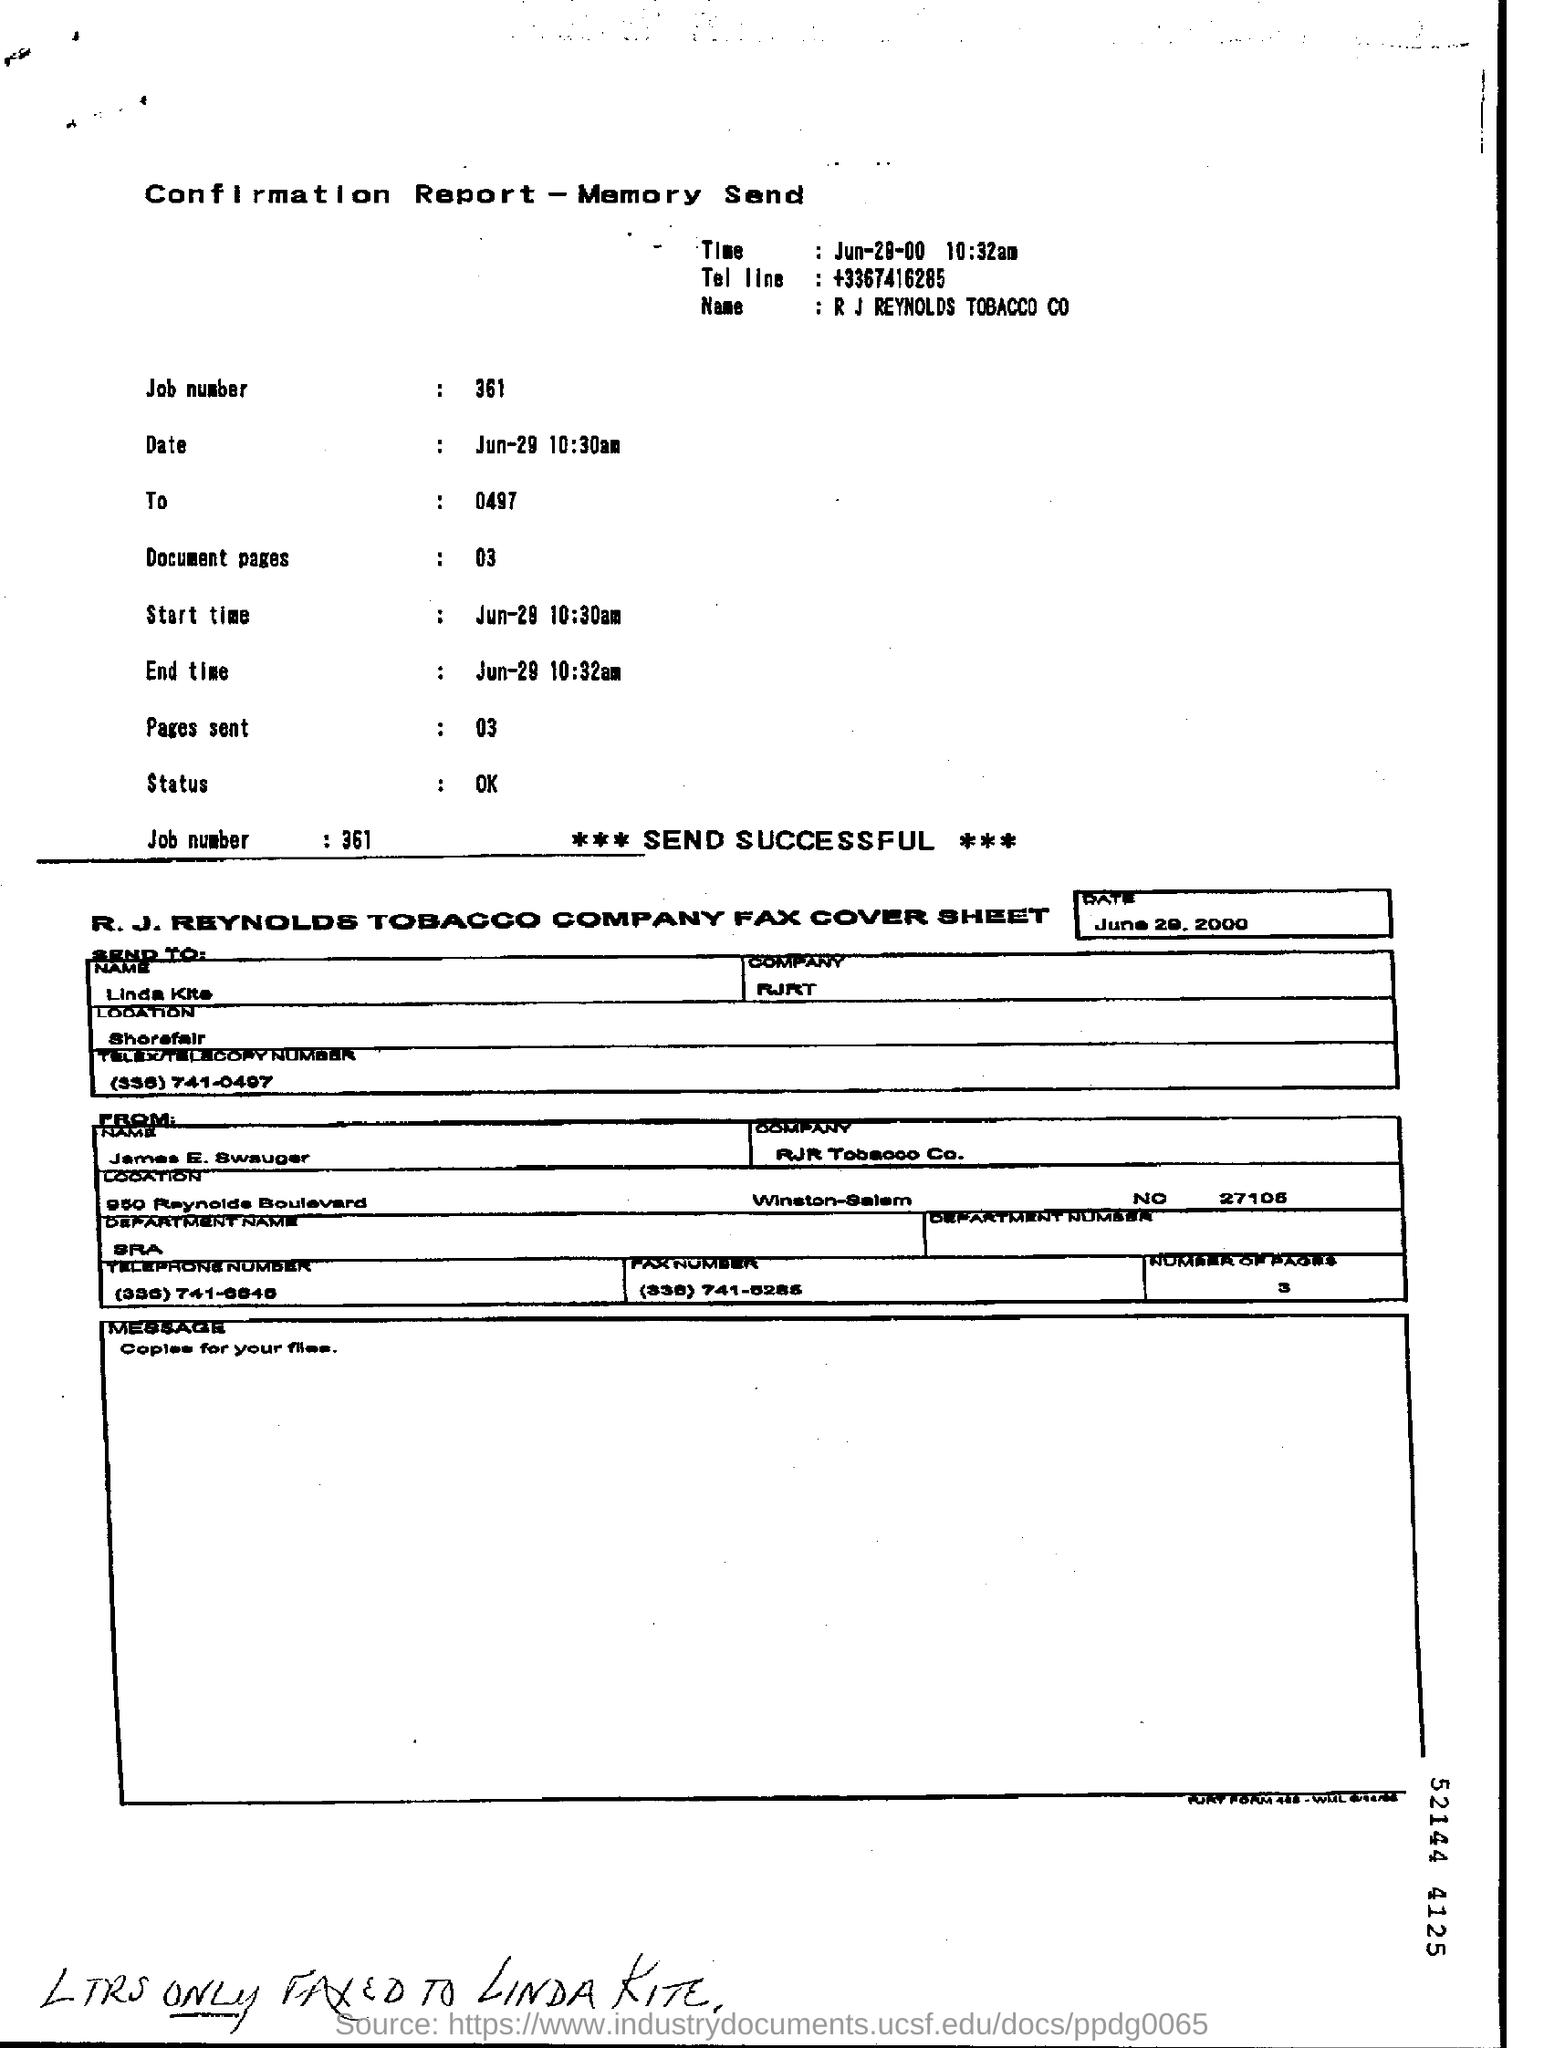What is the Tel line?
Ensure brevity in your answer.  +3367416285. What is the job number?
Your answer should be very brief. 361. How many document pages?
Ensure brevity in your answer.  03. To whom is the fax addressed?
Offer a terse response. Linda Kite. What is the message on the fax?
Your response must be concise. Copies for your files. 